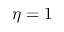<formula> <loc_0><loc_0><loc_500><loc_500>\eta = 1</formula> 